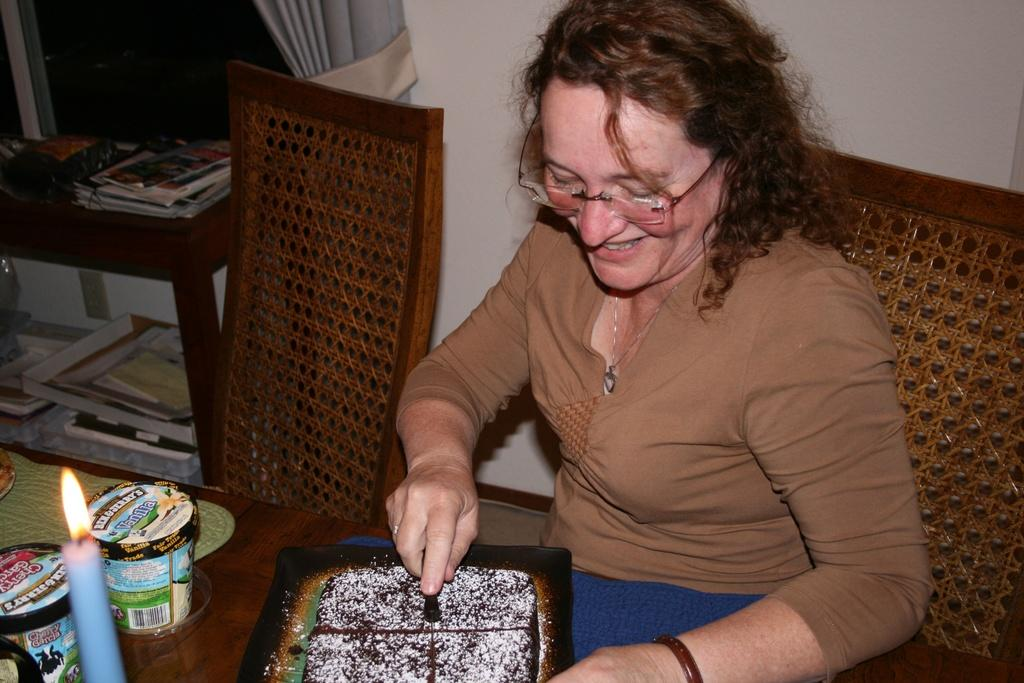What is the woman in the image doing? The woman is sitting on a chair in the image. What expression does the woman have? The woman is smiling. What accessory is the woman wearing? The woman is wearing glasses (specs). What is on the table in the image? There is a cake, a candle, and cups on the table. What type of corn can be seen growing on the mountain in the image? There is no corn or mountain present in the image; it features a woman sitting on a chair, smiling, and wearing glasses, with a table containing a cake, a candle, and cups. 